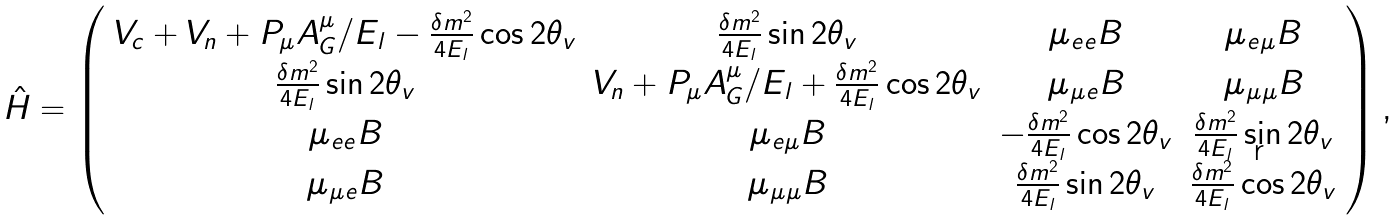<formula> <loc_0><loc_0><loc_500><loc_500>\hat { H } = \left ( \begin{array} { c c c c } V _ { c } + V _ { n } + P _ { \mu } A ^ { \mu } _ { G } / E _ { l } - \frac { \delta m ^ { 2 } } { 4 E _ { l } } \cos 2 \theta _ { v } & \frac { \delta m ^ { 2 } } { 4 E _ { l } } \sin 2 \theta _ { v } & \mu _ { e e } B & \mu _ { e \mu } B \\ \frac { \delta m ^ { 2 } } { 4 E _ { l } } \sin 2 \theta _ { v } & V _ { n } + P _ { \mu } A ^ { \mu } _ { G } / E _ { l } + \frac { \delta m ^ { 2 } } { 4 E _ { l } } \cos 2 \theta _ { v } & \mu _ { \mu e } B & \mu _ { \mu \mu } B \\ \mu _ { e e } B & \mu _ { e \mu } B & - \frac { \delta m ^ { 2 } } { 4 E _ { l } } \cos 2 \theta _ { v } & \frac { \delta m ^ { 2 } } { 4 E _ { l } } \sin 2 \theta _ { v } \\ \mu _ { \mu e } B & \mu _ { \mu \mu } B & \frac { \delta m ^ { 2 } } { 4 E _ { l } } \sin 2 \theta _ { v } & \frac { \delta m ^ { 2 } } { 4 E _ { l } } \cos 2 \theta _ { v } \end{array} \right ) ,</formula> 